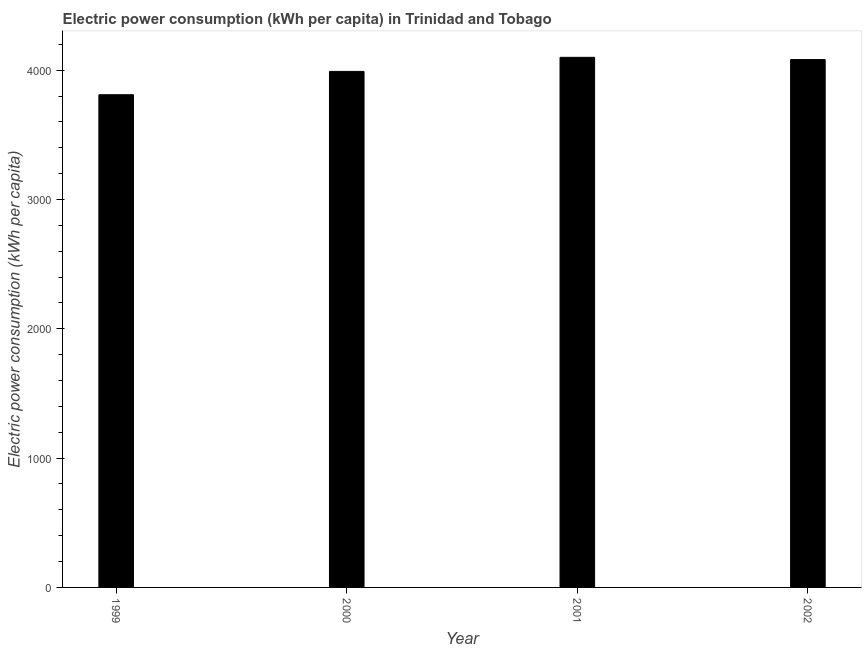Does the graph contain any zero values?
Offer a terse response. No. What is the title of the graph?
Keep it short and to the point. Electric power consumption (kWh per capita) in Trinidad and Tobago. What is the label or title of the X-axis?
Offer a very short reply. Year. What is the label or title of the Y-axis?
Keep it short and to the point. Electric power consumption (kWh per capita). What is the electric power consumption in 2001?
Provide a succinct answer. 4099.39. Across all years, what is the maximum electric power consumption?
Your response must be concise. 4099.39. Across all years, what is the minimum electric power consumption?
Keep it short and to the point. 3810.15. In which year was the electric power consumption maximum?
Give a very brief answer. 2001. What is the sum of the electric power consumption?
Give a very brief answer. 1.60e+04. What is the difference between the electric power consumption in 1999 and 2001?
Give a very brief answer. -289.25. What is the average electric power consumption per year?
Provide a short and direct response. 3995.51. What is the median electric power consumption?
Offer a very short reply. 4036.24. In how many years, is the electric power consumption greater than 1600 kWh per capita?
Your response must be concise. 4. Do a majority of the years between 2002 and 1999 (inclusive) have electric power consumption greater than 2800 kWh per capita?
Give a very brief answer. Yes. What is the ratio of the electric power consumption in 1999 to that in 2000?
Provide a succinct answer. 0.95. Is the electric power consumption in 1999 less than that in 2002?
Keep it short and to the point. Yes. What is the difference between the highest and the second highest electric power consumption?
Provide a succinct answer. 17.51. What is the difference between the highest and the lowest electric power consumption?
Give a very brief answer. 289.25. How many bars are there?
Keep it short and to the point. 4. How many years are there in the graph?
Provide a short and direct response. 4. What is the difference between two consecutive major ticks on the Y-axis?
Provide a succinct answer. 1000. What is the Electric power consumption (kWh per capita) in 1999?
Offer a very short reply. 3810.15. What is the Electric power consumption (kWh per capita) in 2000?
Offer a very short reply. 3990.6. What is the Electric power consumption (kWh per capita) in 2001?
Offer a very short reply. 4099.39. What is the Electric power consumption (kWh per capita) in 2002?
Provide a succinct answer. 4081.89. What is the difference between the Electric power consumption (kWh per capita) in 1999 and 2000?
Offer a very short reply. -180.45. What is the difference between the Electric power consumption (kWh per capita) in 1999 and 2001?
Your answer should be compact. -289.25. What is the difference between the Electric power consumption (kWh per capita) in 1999 and 2002?
Make the answer very short. -271.74. What is the difference between the Electric power consumption (kWh per capita) in 2000 and 2001?
Your answer should be compact. -108.8. What is the difference between the Electric power consumption (kWh per capita) in 2000 and 2002?
Your response must be concise. -91.29. What is the difference between the Electric power consumption (kWh per capita) in 2001 and 2002?
Ensure brevity in your answer.  17.51. What is the ratio of the Electric power consumption (kWh per capita) in 1999 to that in 2000?
Ensure brevity in your answer.  0.95. What is the ratio of the Electric power consumption (kWh per capita) in 1999 to that in 2001?
Make the answer very short. 0.93. What is the ratio of the Electric power consumption (kWh per capita) in 1999 to that in 2002?
Your answer should be very brief. 0.93. What is the ratio of the Electric power consumption (kWh per capita) in 2000 to that in 2001?
Offer a very short reply. 0.97. 